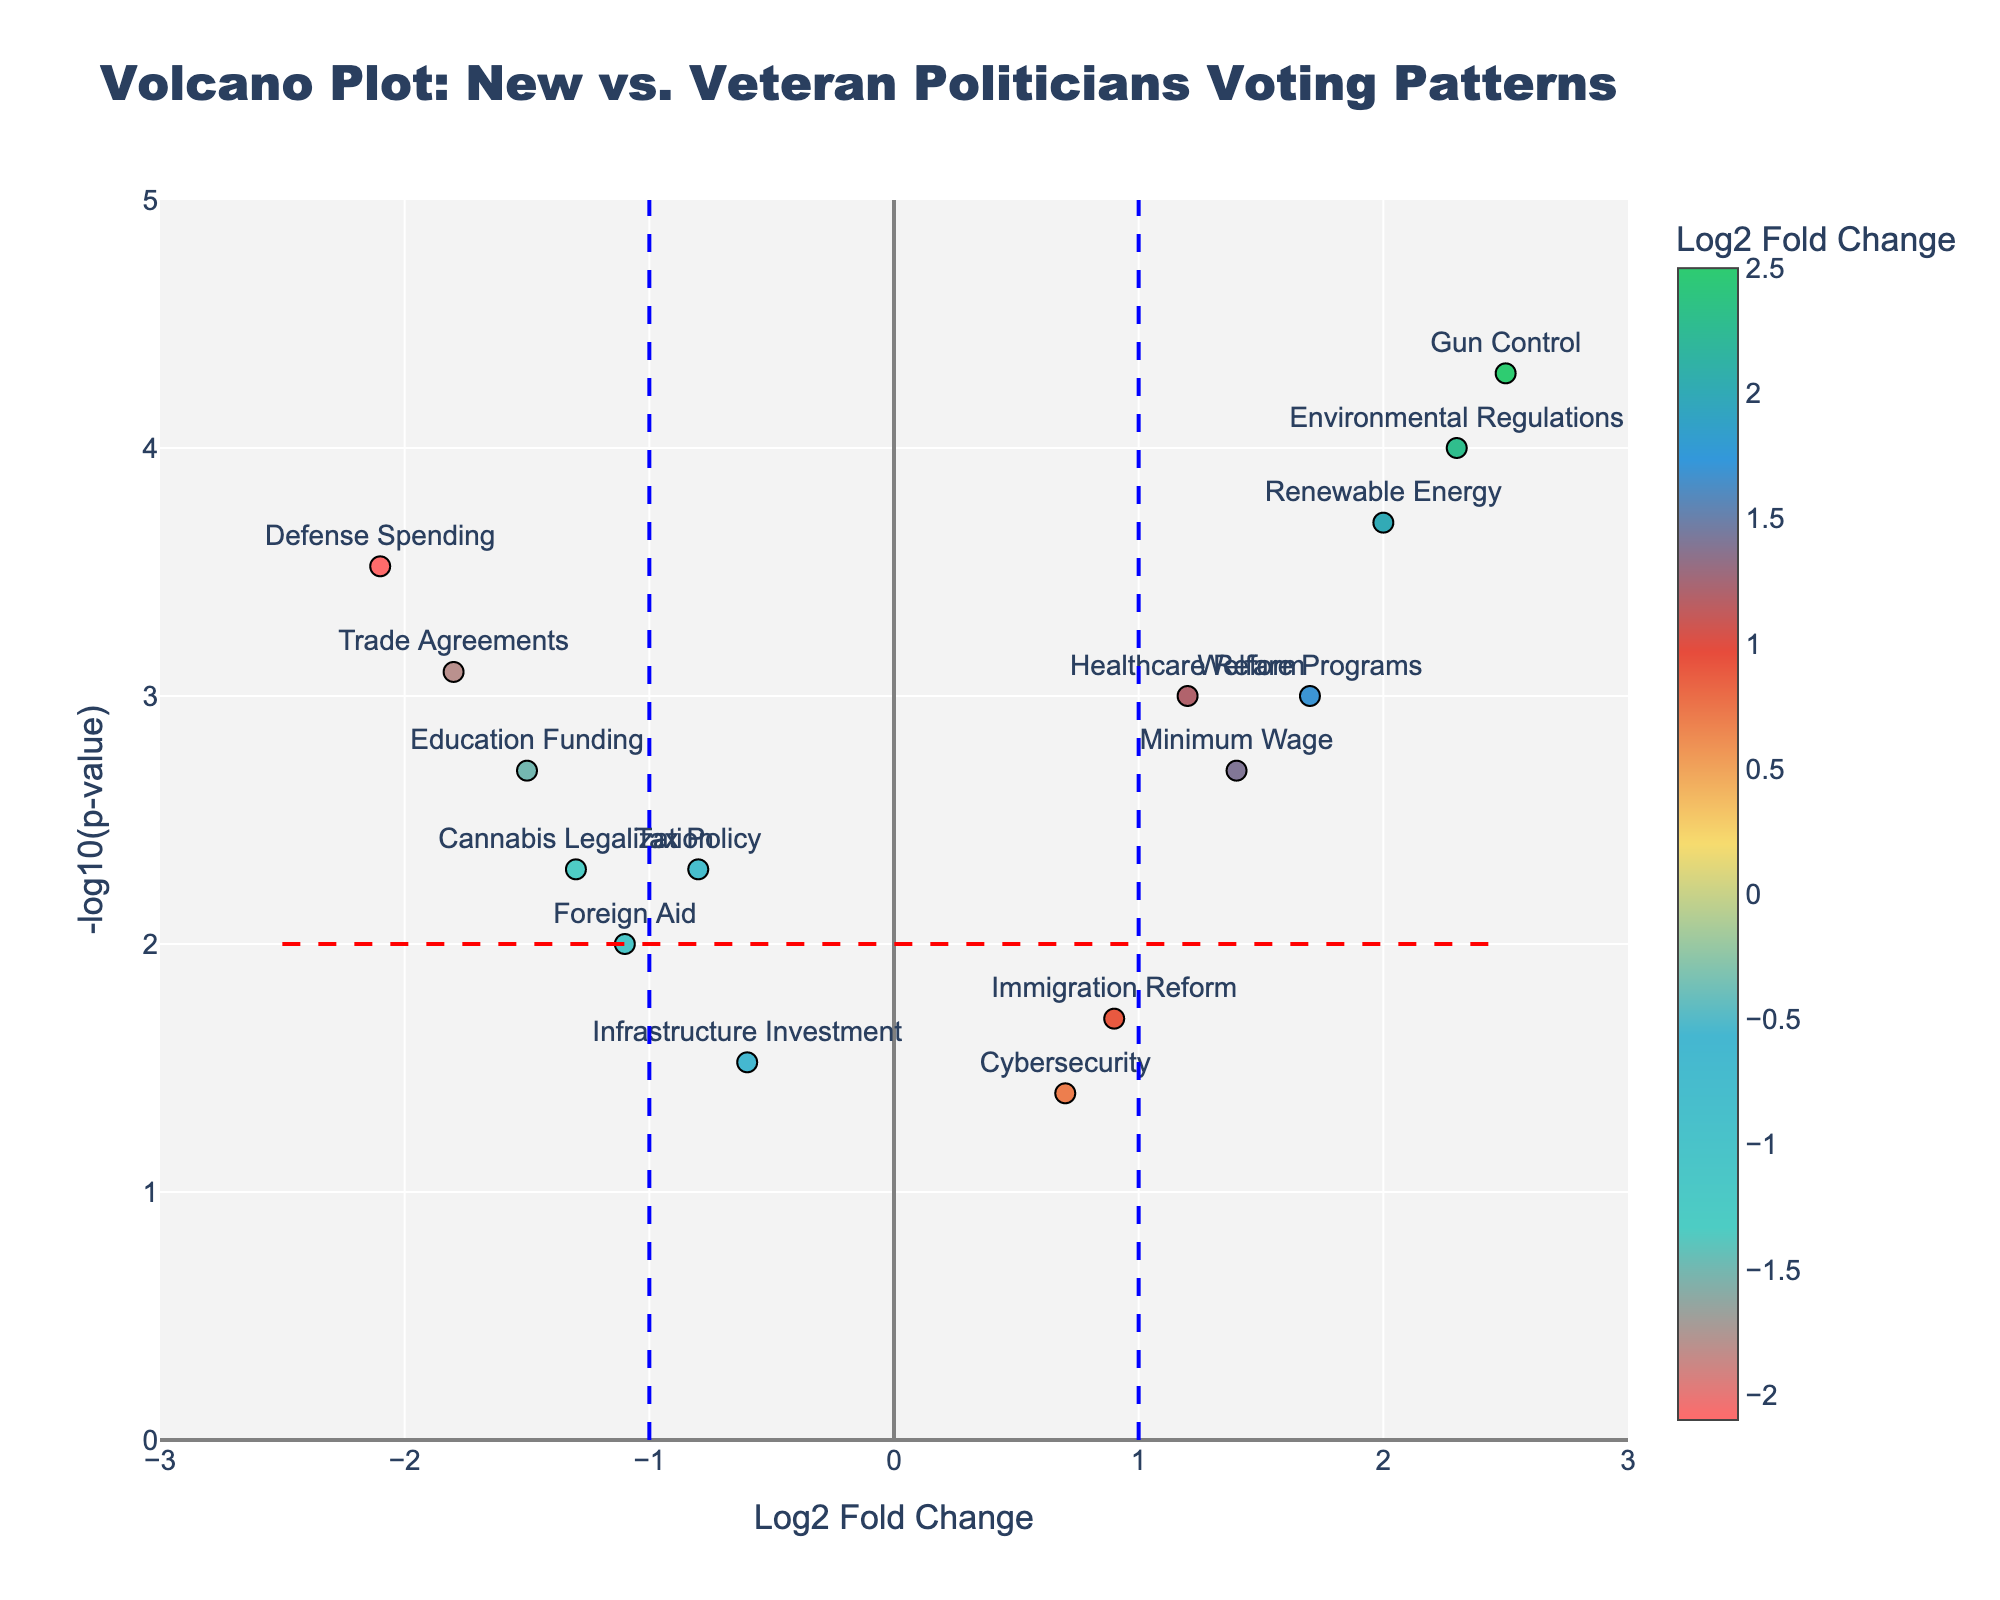How many vote types are shown in the figure? There are markers in the plot, each labeled with a vote type. Counting each one gives the total.
Answer: 15 What are the vote types near the highest Log2 Fold Change values? Look at the right-most end of the x-axis for highest Log2 Fold Change values and identify the text labels.
Answer: Environmental Regulations, Gun Control, Renewable Energy Which vote type has the highest -log10(p-value)? Look at the point with the highest y-axis value and read the text label next to it.
Answer: Gun Control How many vote types have a positive Log2 Fold Change and a -log10(p-value) greater than 3? Identify the markers on the upper-right quadrant where both conditions are met and count them.
Answer: 3 How does the vote type for Foreign Aid compare to Healthcare Reform in terms of Log2 Fold Change? Compare the x-axis values of Foreign Aid and Healthcare Reform. Foreign Aid has a negative Log2 Fold Change, while Healthcare Reform has a positive Log2 Fold Change.
Answer: Foreign Aid's Log2 Fold Change is lower Which vote types have a significant p-value threshold (below 0.001), considering both positive and negative Log2 Fold Changes? Identify the points where -log10(p-value) is greater than 3, then check their Log2 Fold Change values and note their text labels.
Answer: Environmental Regulations, Defense Spending, Gun Control, Renewable Energy What vote types cluster around a Log2 Fold Change of 0 and -log10(p-value) of less than 2? Identify the points near the center-bottom of the plot and read their text labels.
Answer: Immigration Reform, Foreign Aid, Infrastructure Investment, Cybersecurity What can be said about the political stance regarding Education Funding versus Defense Spending based on their Log2 Fold Change and p-values? Compare the Log2 Fold Change and -log10(p-value) for both Education Funding and Defense Spending. The negative Log2 Fold Change values suggest they are more supported by veteran politicians. Both have significant p-values.
Answer: Both are more supported by veterans, with significant p-values Which vote type has the most extreme negative Log2 Fold Change? Identify the lowest x-axis value and read the corresponding text label.
Answer: Defense Spending 